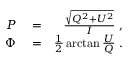<formula> <loc_0><loc_0><loc_500><loc_500>\begin{array} { r l r } { P } & = } & { \frac { \sqrt { Q ^ { 2 } + U ^ { 2 } } } { I } \, , } \\ { \Phi } & = } & { \frac { 1 } { 2 } \arctan { \frac { U } { Q } } \, . } \end{array}</formula> 